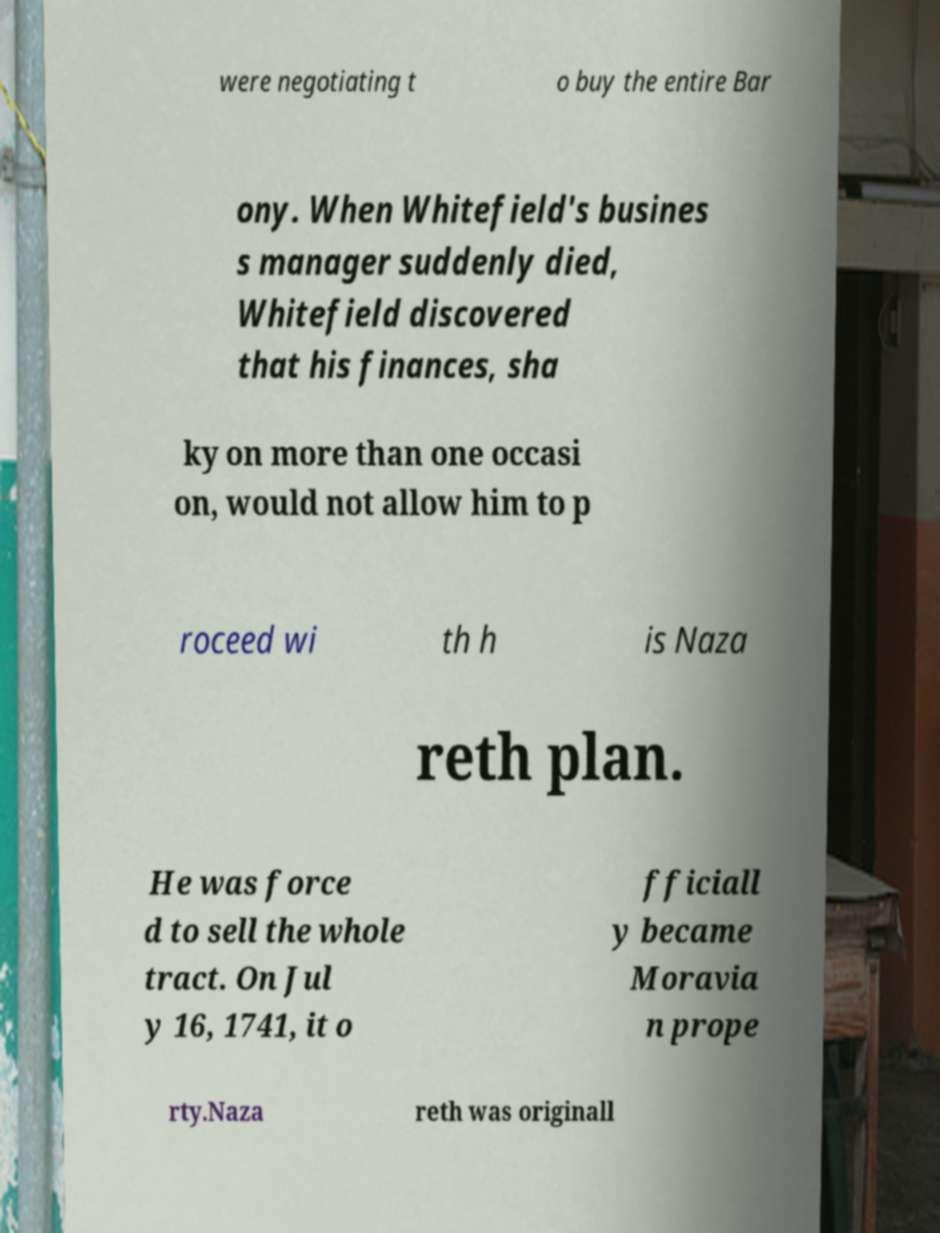Please identify and transcribe the text found in this image. were negotiating t o buy the entire Bar ony. When Whitefield's busines s manager suddenly died, Whitefield discovered that his finances, sha ky on more than one occasi on, would not allow him to p roceed wi th h is Naza reth plan. He was force d to sell the whole tract. On Jul y 16, 1741, it o fficiall y became Moravia n prope rty.Naza reth was originall 